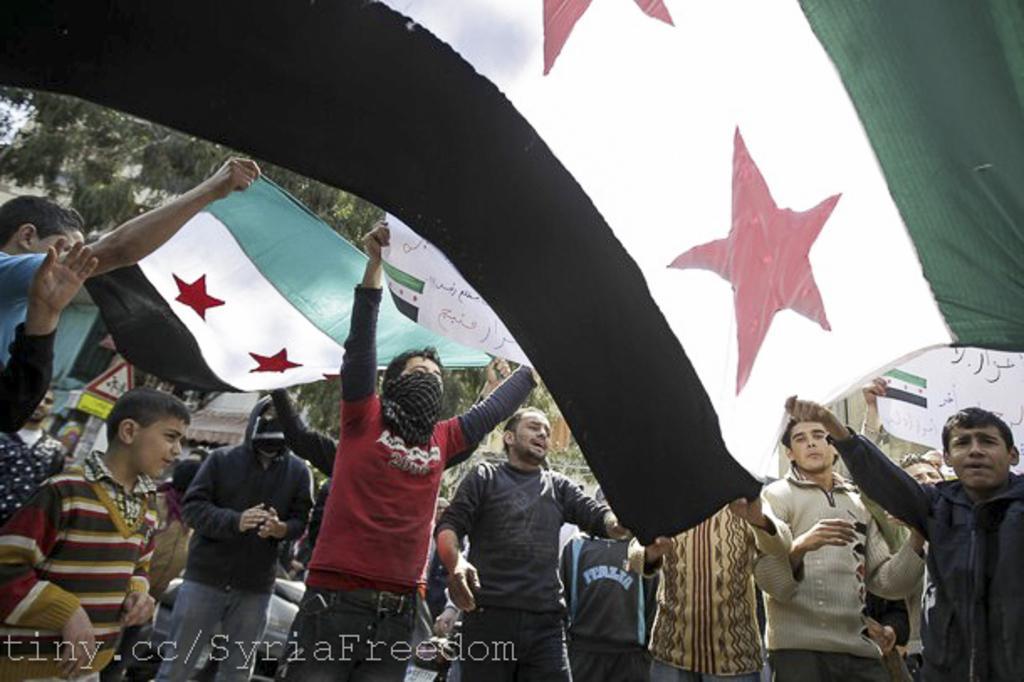Describe this image in one or two sentences. In this picture there are some people who are standing and holding the flag. 